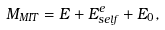<formula> <loc_0><loc_0><loc_500><loc_500>M _ { M I T } = E + E _ { s e l f } ^ { e } + E _ { 0 } ,</formula> 